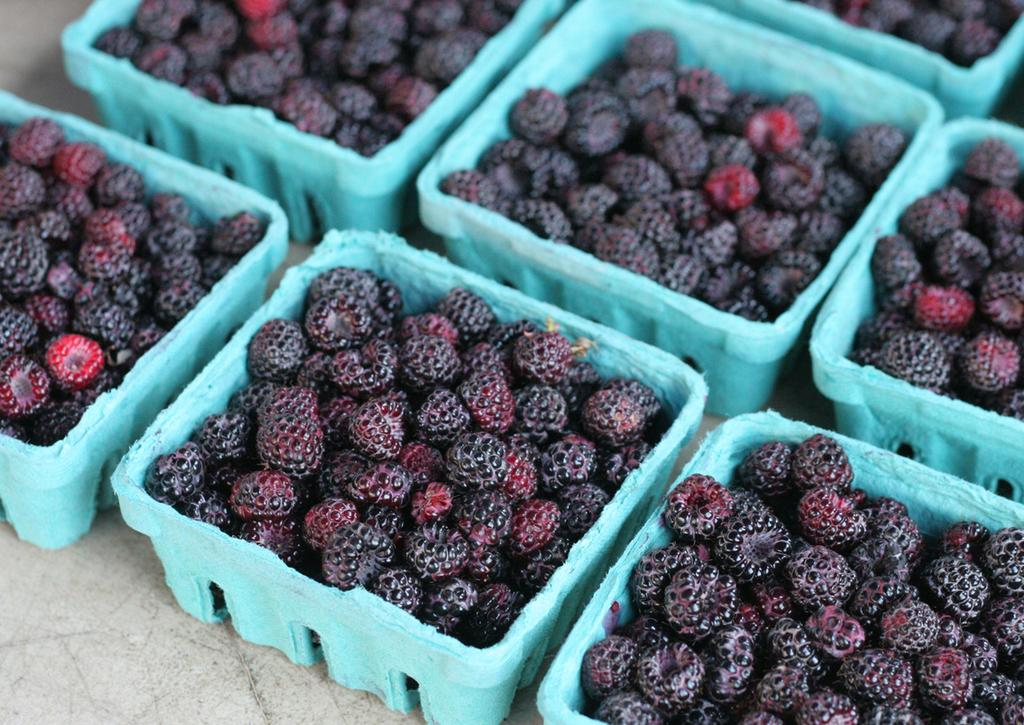What type of fruit is present in the image? There are boxes with raspberries in the image. Where are the raspberries stored in the image? The boxes with raspberries are kept on an object. What day of the week is mentioned on the calendar in the image? There is no calendar present in the image, so it is not possible to determine the day of the week. 